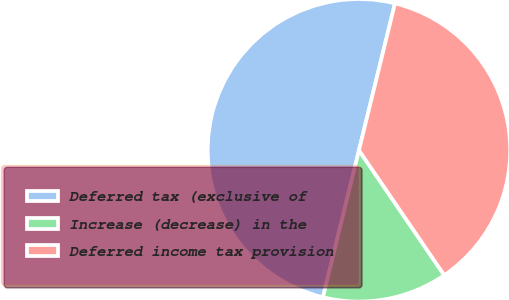Convert chart. <chart><loc_0><loc_0><loc_500><loc_500><pie_chart><fcel>Deferred tax (exclusive of<fcel>Increase (decrease) in the<fcel>Deferred income tax provision<nl><fcel>50.0%<fcel>13.36%<fcel>36.64%<nl></chart> 